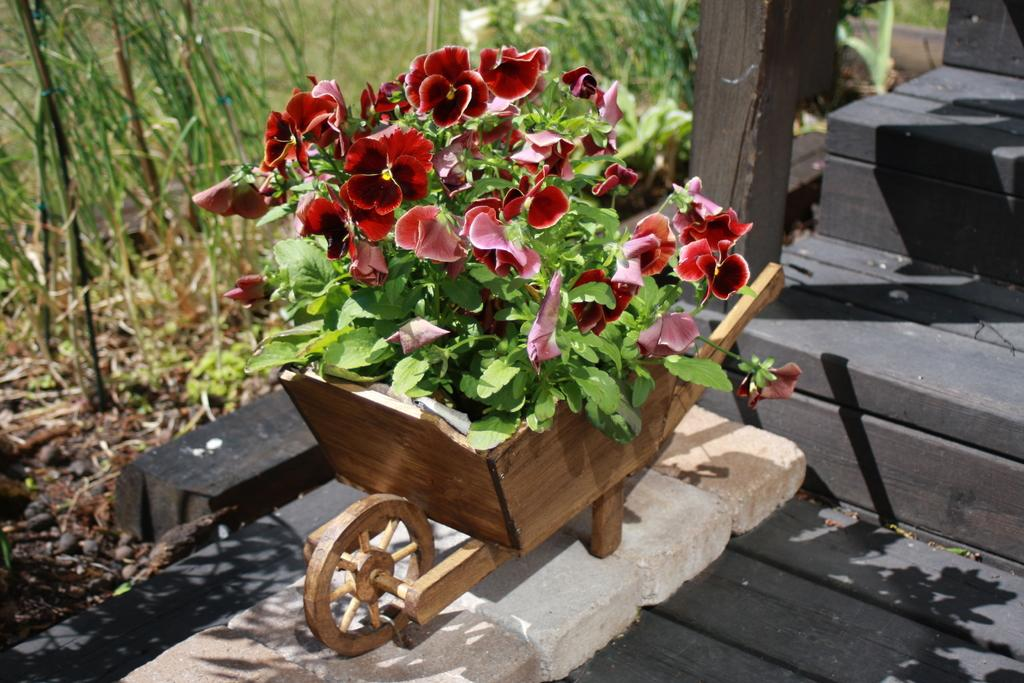What is located in the center of the image? There are flowers and a plant in the center of the image. What type of object is on stones in the center of the image? There is a cart-like object on stones in the center of the image. What architectural feature can be seen on the right side of the image? There is a staircase on the right side of the image. What type of vegetation is visible in the background of the image? There are plants and grass in the background of the image. How many women are holding apples at the top of the image? There are no women or apples present in the image. What type of creature is shown interacting with the cart-like object on stones in the image? There is no creature shown interacting with the cart-like object on stones in the image; only the cart-like object, flowers, and plant are present. 